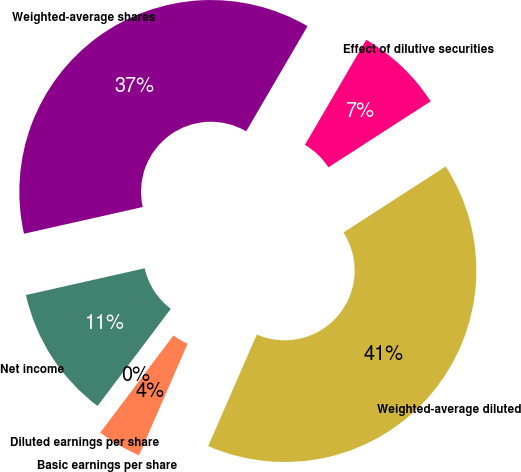Convert chart to OTSL. <chart><loc_0><loc_0><loc_500><loc_500><pie_chart><fcel>Net income<fcel>Weighted-average shares<fcel>Effect of dilutive securities<fcel>Weighted-average diluted<fcel>Basic earnings per share<fcel>Diluted earnings per share<nl><fcel>11.2%<fcel>36.93%<fcel>7.47%<fcel>40.66%<fcel>3.74%<fcel>0.0%<nl></chart> 